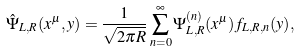Convert formula to latex. <formula><loc_0><loc_0><loc_500><loc_500>\hat { \Psi } _ { L , R } ( x ^ { \mu } , y ) = \frac { 1 } { \sqrt { 2 \pi R } } \sum _ { n = 0 } ^ { \infty } \Psi ^ { ( n ) } _ { L , R } ( x ^ { \mu } ) f _ { L , R , n } ( y ) ,</formula> 